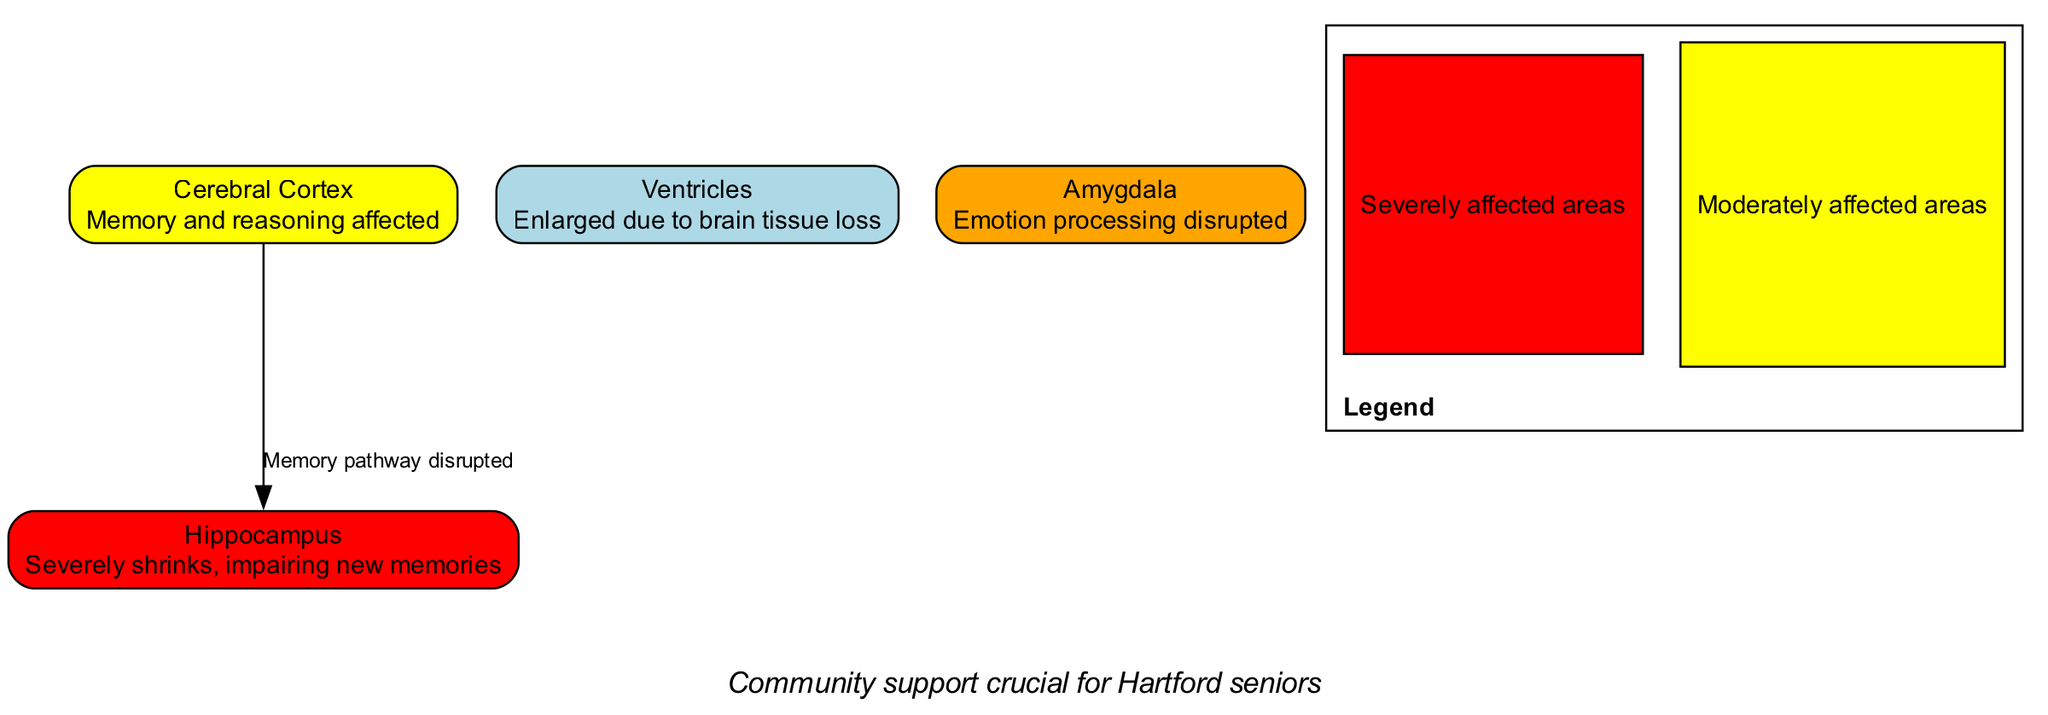What area is severely affected by Alzheimer's disease? The diagram highlights the Hippocampus as severely affected, indicated by its red color. This area is described as severely shrinking, thereby impairing new memories.
Answer: Hippocampus What is the function of the Cerebral Cortex as depicted in the diagram? According to the diagram, the Cerebral Cortex is associated with memory and reasoning, both of which are affected by Alzheimer's disease. This is evident from its description in the diagram.
Answer: Memory and reasoning How many nodes are present in the diagram? The diagram includes four nodes: Cerebral Cortex, Hippocampus, Ventricles, and Amygdala. By counting these distinct nodes, the total comes to four.
Answer: Four What does the enlarged Ventricle signify in the context of Alzheimer's disease? The diagram indicates that an enlarged Ventricle is due to brain tissue loss, which is a common symptom associated with Alzheimer's. This indicates the progression and impact of the disease on the brain's structure.
Answer: Brain tissue loss What relationship exists between the Cerebral Cortex and the Hippocampus? The diagram shows a direct relationship where the edge labeled "Memory pathway disrupted" connects the Cerebral Cortex to the Hippocampus, signifying a disrupted communication or function between these two areas.
Answer: Memory pathway disrupted Which area is responsible for emotion processing, as indicated in the diagram? The diagram highlights the Amygdala as the area responsible for emotion processing, although it notes that this function is disrupted due to Alzheimer's disease.
Answer: Amygdala What color indicates severely affected areas in the diagram? The legend in the diagram specifies that red represents severely affected areas. In this context, it is used to designate the Hippocampus.
Answer: Red How does community support relate to the diagram? The annotation at the bottom of the diagram emphasizes that community support is crucial for Hartford seniors affected by Alzheimer's, highlighting the significance of communal efforts in facing adversity.
Answer: Community support crucial for Hartford seniors 